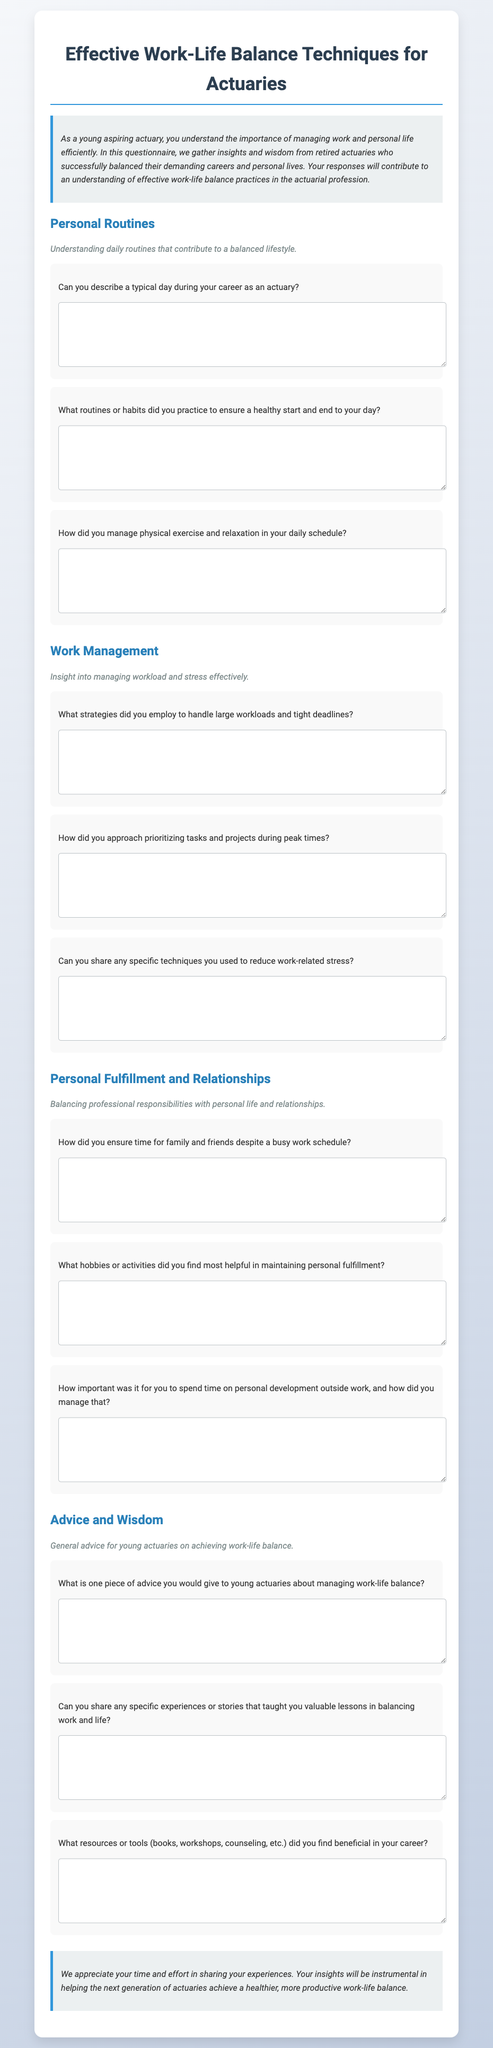What is the title of the document? The title of the document is indicated in the heading element and describes the content of the questionnaire.
Answer: Effective Work-Life Balance Techniques for Actuaries How many sections are present in the document? The document consists of multiple distinct sections that cover different topics related to work-life balance and is explicitly divided into these sections.
Answer: Four What is the focus of the 'Advice and Wisdom' section? This section aims to gather general advice and insights specifically targeted towards young actuaries regarding achieving work-life balance.
Answer: General advice What type of questions are included in the 'Personal Routines' section? The questions in this section inquire about daily habits and routines that contribute to maintaining a healthy lifestyle.
Answer: Daily routines What is one example of a question found in the 'Work Management' section? This section includes questions designed to explore strategies for managing workloads and reducing stress, demonstrating specific focus areas.
Answer: What strategies did you employ to handle large workloads and tight deadlines? How are responses structured in the document? The document prompts for open-ended responses to each question, encouraging detailed inputs in the form of written answers.
Answer: Textarea 